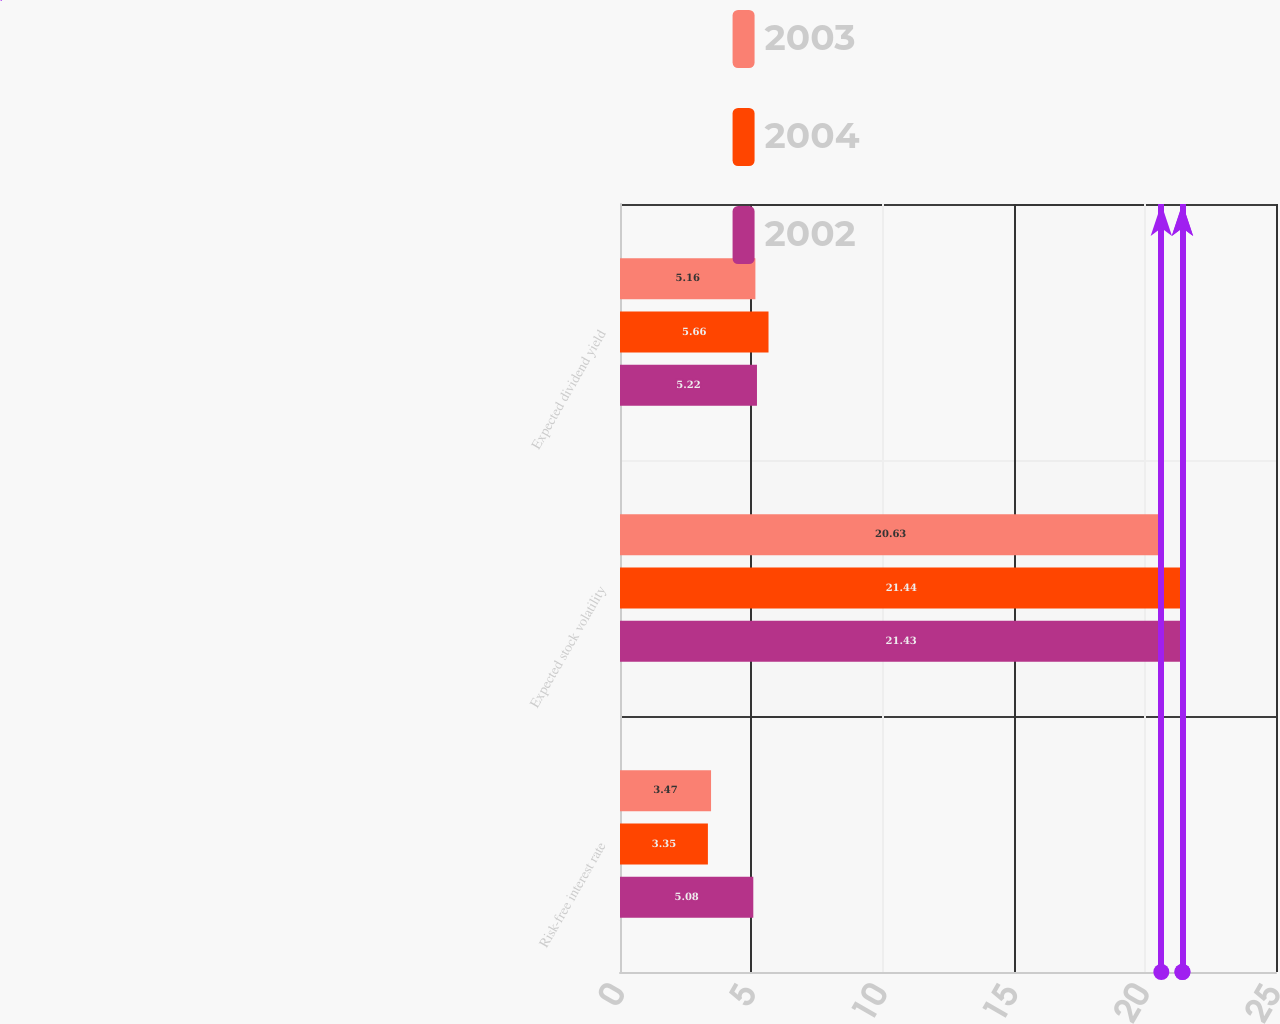<chart> <loc_0><loc_0><loc_500><loc_500><stacked_bar_chart><ecel><fcel>Risk-free interest rate<fcel>Expected stock volatility<fcel>Expected dividend yield<nl><fcel>2003<fcel>3.47<fcel>20.63<fcel>5.16<nl><fcel>2004<fcel>3.35<fcel>21.44<fcel>5.66<nl><fcel>2002<fcel>5.08<fcel>21.43<fcel>5.22<nl></chart> 